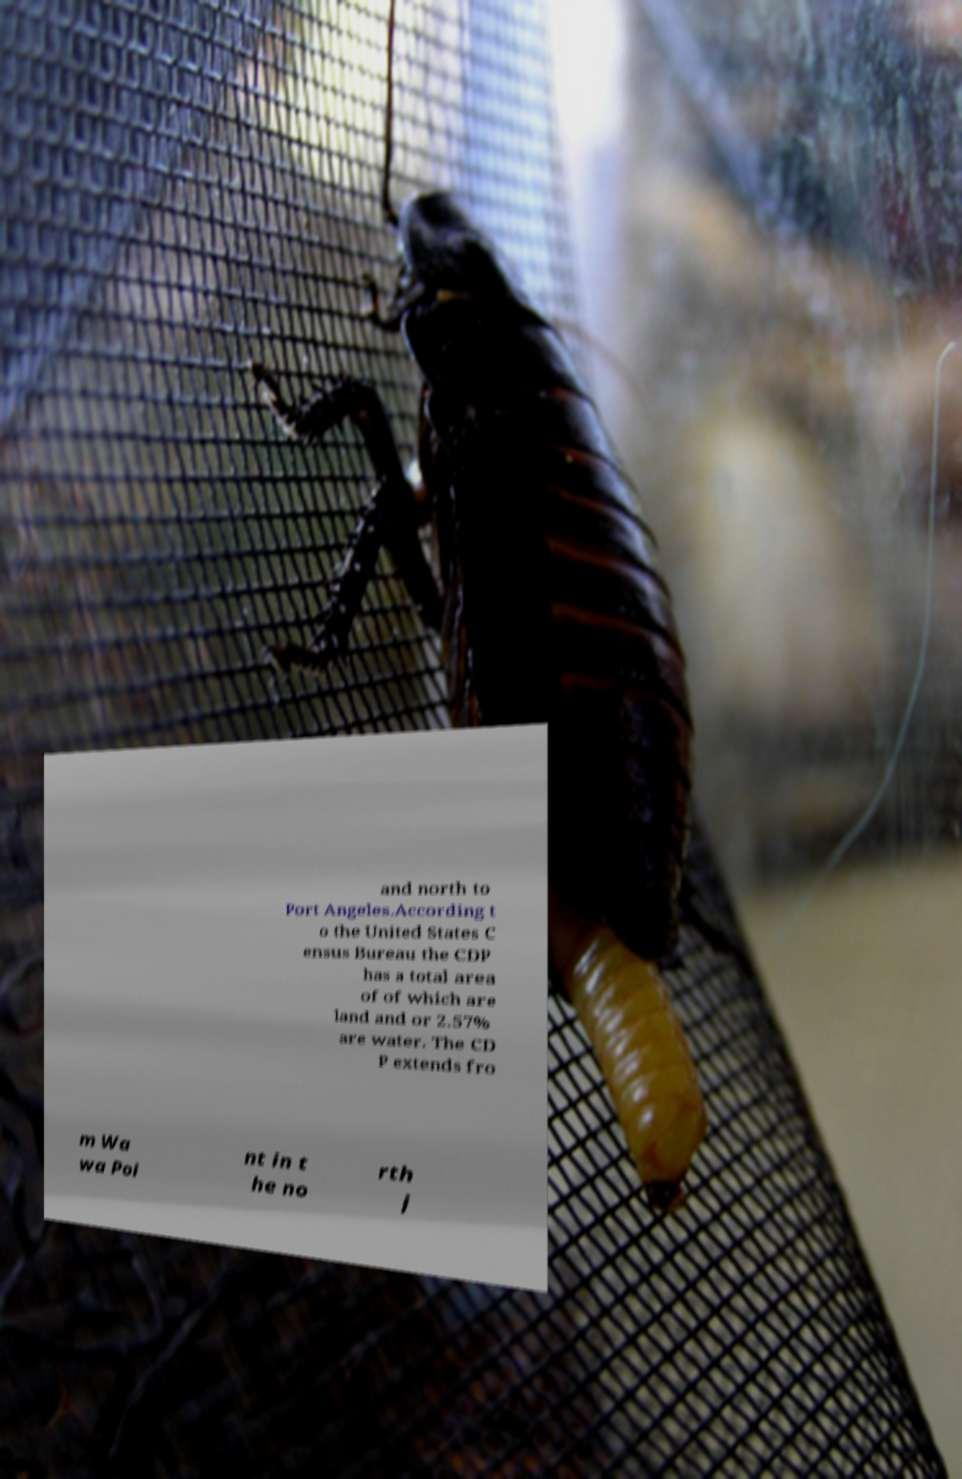Can you read and provide the text displayed in the image?This photo seems to have some interesting text. Can you extract and type it out for me? and north to Port Angeles.According t o the United States C ensus Bureau the CDP has a total area of of which are land and or 2.57% are water. The CD P extends fro m Wa wa Poi nt in t he no rth j 